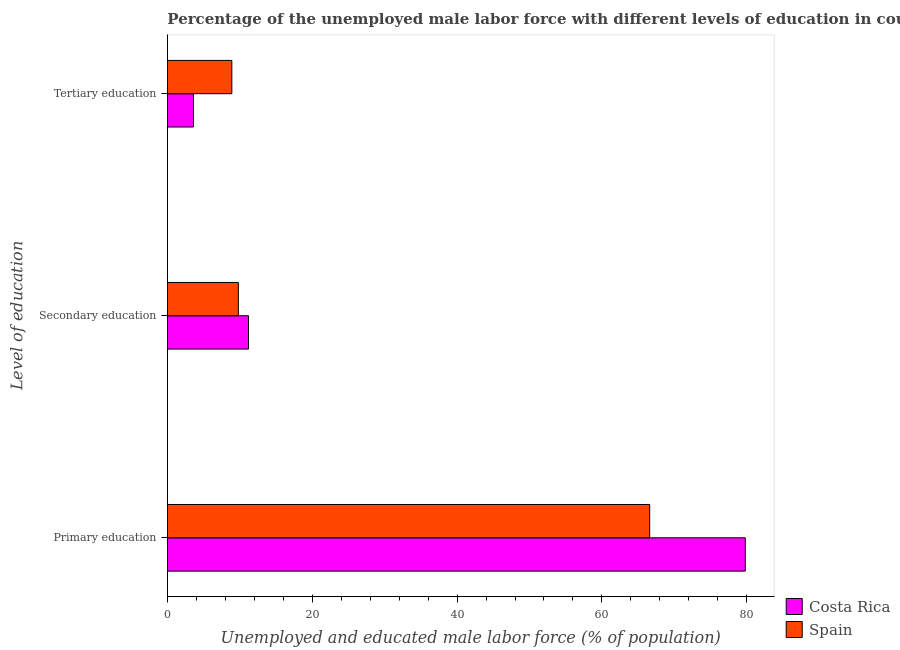How many different coloured bars are there?
Provide a short and direct response. 2. How many groups of bars are there?
Give a very brief answer. 3. Are the number of bars per tick equal to the number of legend labels?
Your answer should be very brief. Yes. What is the label of the 1st group of bars from the top?
Give a very brief answer. Tertiary education. What is the percentage of male labor force who received primary education in Costa Rica?
Your response must be concise. 79.8. Across all countries, what is the maximum percentage of male labor force who received secondary education?
Make the answer very short. 11.2. Across all countries, what is the minimum percentage of male labor force who received primary education?
Ensure brevity in your answer.  66.6. What is the total percentage of male labor force who received tertiary education in the graph?
Offer a terse response. 12.5. What is the difference between the percentage of male labor force who received tertiary education in Costa Rica and that in Spain?
Keep it short and to the point. -5.3. What is the difference between the percentage of male labor force who received secondary education in Spain and the percentage of male labor force who received primary education in Costa Rica?
Make the answer very short. -70. What is the average percentage of male labor force who received primary education per country?
Keep it short and to the point. 73.2. What is the difference between the percentage of male labor force who received primary education and percentage of male labor force who received secondary education in Costa Rica?
Provide a short and direct response. 68.6. In how many countries, is the percentage of male labor force who received secondary education greater than 44 %?
Keep it short and to the point. 0. What is the ratio of the percentage of male labor force who received primary education in Costa Rica to that in Spain?
Your answer should be very brief. 1.2. Is the difference between the percentage of male labor force who received secondary education in Spain and Costa Rica greater than the difference between the percentage of male labor force who received primary education in Spain and Costa Rica?
Ensure brevity in your answer.  Yes. What is the difference between the highest and the second highest percentage of male labor force who received tertiary education?
Your answer should be compact. 5.3. What is the difference between the highest and the lowest percentage of male labor force who received primary education?
Your answer should be very brief. 13.2. In how many countries, is the percentage of male labor force who received tertiary education greater than the average percentage of male labor force who received tertiary education taken over all countries?
Your response must be concise. 1. Is the sum of the percentage of male labor force who received primary education in Spain and Costa Rica greater than the maximum percentage of male labor force who received tertiary education across all countries?
Keep it short and to the point. Yes. What does the 1st bar from the top in Secondary education represents?
Offer a very short reply. Spain. What does the 2nd bar from the bottom in Secondary education represents?
Your answer should be very brief. Spain. Is it the case that in every country, the sum of the percentage of male labor force who received primary education and percentage of male labor force who received secondary education is greater than the percentage of male labor force who received tertiary education?
Make the answer very short. Yes. How many countries are there in the graph?
Offer a terse response. 2. What is the difference between two consecutive major ticks on the X-axis?
Give a very brief answer. 20. Where does the legend appear in the graph?
Your response must be concise. Bottom right. How are the legend labels stacked?
Offer a terse response. Vertical. What is the title of the graph?
Provide a succinct answer. Percentage of the unemployed male labor force with different levels of education in countries. Does "Slovak Republic" appear as one of the legend labels in the graph?
Your answer should be compact. No. What is the label or title of the X-axis?
Offer a terse response. Unemployed and educated male labor force (% of population). What is the label or title of the Y-axis?
Give a very brief answer. Level of education. What is the Unemployed and educated male labor force (% of population) in Costa Rica in Primary education?
Offer a very short reply. 79.8. What is the Unemployed and educated male labor force (% of population) in Spain in Primary education?
Ensure brevity in your answer.  66.6. What is the Unemployed and educated male labor force (% of population) in Costa Rica in Secondary education?
Provide a short and direct response. 11.2. What is the Unemployed and educated male labor force (% of population) in Spain in Secondary education?
Provide a succinct answer. 9.8. What is the Unemployed and educated male labor force (% of population) in Costa Rica in Tertiary education?
Provide a short and direct response. 3.6. What is the Unemployed and educated male labor force (% of population) of Spain in Tertiary education?
Offer a very short reply. 8.9. Across all Level of education, what is the maximum Unemployed and educated male labor force (% of population) in Costa Rica?
Your answer should be very brief. 79.8. Across all Level of education, what is the maximum Unemployed and educated male labor force (% of population) in Spain?
Make the answer very short. 66.6. Across all Level of education, what is the minimum Unemployed and educated male labor force (% of population) in Costa Rica?
Offer a very short reply. 3.6. Across all Level of education, what is the minimum Unemployed and educated male labor force (% of population) in Spain?
Make the answer very short. 8.9. What is the total Unemployed and educated male labor force (% of population) in Costa Rica in the graph?
Keep it short and to the point. 94.6. What is the total Unemployed and educated male labor force (% of population) in Spain in the graph?
Provide a short and direct response. 85.3. What is the difference between the Unemployed and educated male labor force (% of population) of Costa Rica in Primary education and that in Secondary education?
Make the answer very short. 68.6. What is the difference between the Unemployed and educated male labor force (% of population) in Spain in Primary education and that in Secondary education?
Ensure brevity in your answer.  56.8. What is the difference between the Unemployed and educated male labor force (% of population) of Costa Rica in Primary education and that in Tertiary education?
Make the answer very short. 76.2. What is the difference between the Unemployed and educated male labor force (% of population) of Spain in Primary education and that in Tertiary education?
Your answer should be very brief. 57.7. What is the difference between the Unemployed and educated male labor force (% of population) of Costa Rica in Secondary education and that in Tertiary education?
Make the answer very short. 7.6. What is the difference between the Unemployed and educated male labor force (% of population) in Costa Rica in Primary education and the Unemployed and educated male labor force (% of population) in Spain in Tertiary education?
Keep it short and to the point. 70.9. What is the difference between the Unemployed and educated male labor force (% of population) in Costa Rica in Secondary education and the Unemployed and educated male labor force (% of population) in Spain in Tertiary education?
Offer a terse response. 2.3. What is the average Unemployed and educated male labor force (% of population) in Costa Rica per Level of education?
Provide a short and direct response. 31.53. What is the average Unemployed and educated male labor force (% of population) in Spain per Level of education?
Offer a terse response. 28.43. What is the ratio of the Unemployed and educated male labor force (% of population) of Costa Rica in Primary education to that in Secondary education?
Provide a short and direct response. 7.12. What is the ratio of the Unemployed and educated male labor force (% of population) of Spain in Primary education to that in Secondary education?
Your answer should be very brief. 6.8. What is the ratio of the Unemployed and educated male labor force (% of population) of Costa Rica in Primary education to that in Tertiary education?
Your response must be concise. 22.17. What is the ratio of the Unemployed and educated male labor force (% of population) of Spain in Primary education to that in Tertiary education?
Your response must be concise. 7.48. What is the ratio of the Unemployed and educated male labor force (% of population) of Costa Rica in Secondary education to that in Tertiary education?
Ensure brevity in your answer.  3.11. What is the ratio of the Unemployed and educated male labor force (% of population) of Spain in Secondary education to that in Tertiary education?
Ensure brevity in your answer.  1.1. What is the difference between the highest and the second highest Unemployed and educated male labor force (% of population) in Costa Rica?
Your answer should be very brief. 68.6. What is the difference between the highest and the second highest Unemployed and educated male labor force (% of population) of Spain?
Keep it short and to the point. 56.8. What is the difference between the highest and the lowest Unemployed and educated male labor force (% of population) of Costa Rica?
Provide a short and direct response. 76.2. What is the difference between the highest and the lowest Unemployed and educated male labor force (% of population) of Spain?
Your response must be concise. 57.7. 